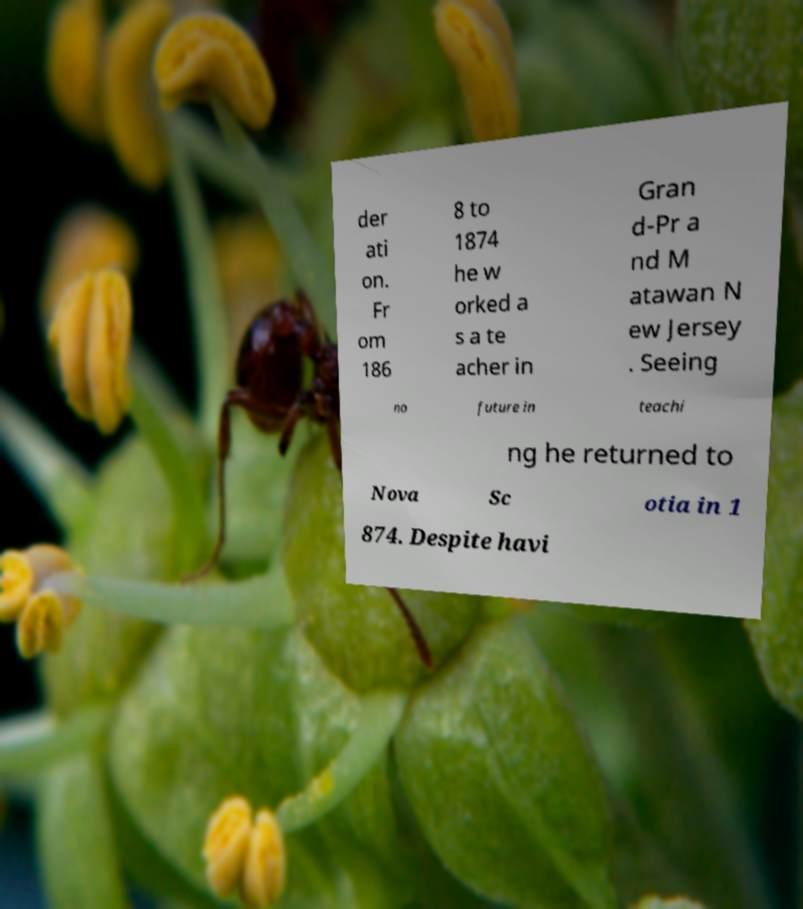Please identify and transcribe the text found in this image. der ati on. Fr om 186 8 to 1874 he w orked a s a te acher in Gran d-Pr a nd M atawan N ew Jersey . Seeing no future in teachi ng he returned to Nova Sc otia in 1 874. Despite havi 